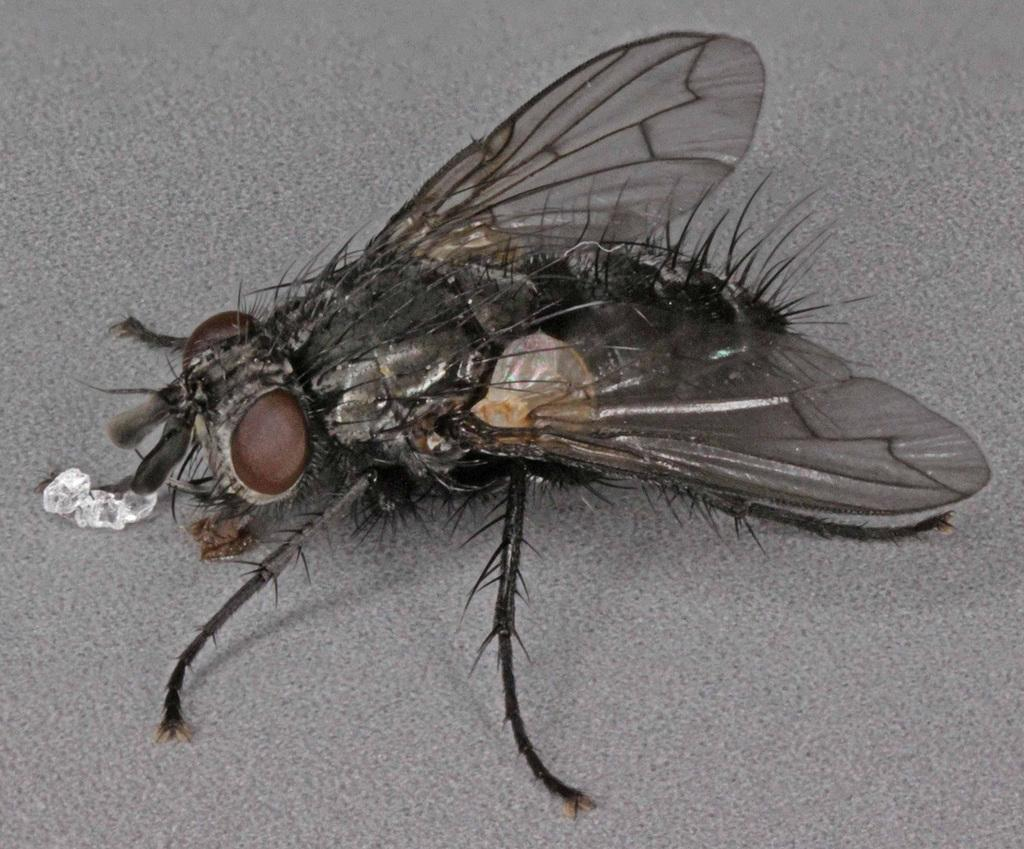What type of creature is in the image? There is an insect in the image. What colors can be seen on the insect? The insect has a black and brown color. Where is the insect located in the image? The insect is on the ash floor. What type of shirt is the insect wearing in the image? Insects do not wear shirts, so this question cannot be answered. 